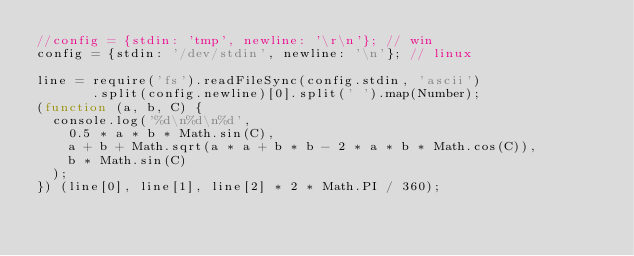Convert code to text. <code><loc_0><loc_0><loc_500><loc_500><_JavaScript_>//config = {stdin: 'tmp', newline: '\r\n'}; // win
config = {stdin: '/dev/stdin', newline: '\n'}; // linux

line = require('fs').readFileSync(config.stdin, 'ascii')
       .split(config.newline)[0].split(' ').map(Number);
(function (a, b, C) {
  console.log('%d\n%d\n%d',
    0.5 * a * b * Math.sin(C),
    a + b + Math.sqrt(a * a + b * b - 2 * a * b * Math.cos(C)),
    b * Math.sin(C)
  );
}) (line[0], line[1], line[2] * 2 * Math.PI / 360);</code> 